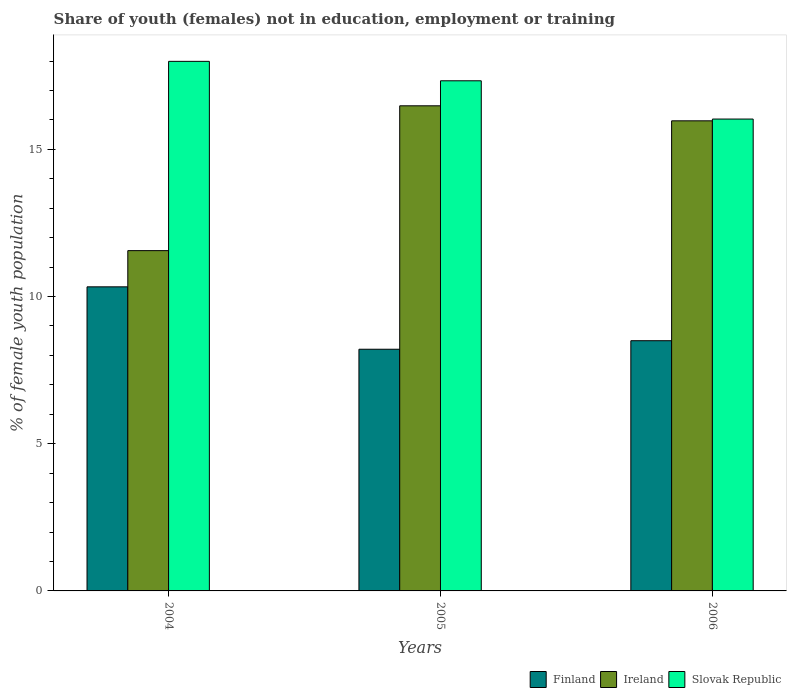How many groups of bars are there?
Give a very brief answer. 3. Are the number of bars on each tick of the X-axis equal?
Make the answer very short. Yes. What is the percentage of unemployed female population in in Slovak Republic in 2004?
Ensure brevity in your answer.  17.99. Across all years, what is the maximum percentage of unemployed female population in in Ireland?
Provide a short and direct response. 16.48. Across all years, what is the minimum percentage of unemployed female population in in Slovak Republic?
Offer a very short reply. 16.03. What is the total percentage of unemployed female population in in Ireland in the graph?
Your response must be concise. 44.01. What is the difference between the percentage of unemployed female population in in Finland in 2004 and that in 2005?
Provide a short and direct response. 2.12. What is the difference between the percentage of unemployed female population in in Ireland in 2005 and the percentage of unemployed female population in in Slovak Republic in 2006?
Make the answer very short. 0.45. What is the average percentage of unemployed female population in in Finland per year?
Keep it short and to the point. 9.01. In the year 2005, what is the difference between the percentage of unemployed female population in in Finland and percentage of unemployed female population in in Slovak Republic?
Keep it short and to the point. -9.12. In how many years, is the percentage of unemployed female population in in Slovak Republic greater than 6 %?
Make the answer very short. 3. What is the ratio of the percentage of unemployed female population in in Slovak Republic in 2005 to that in 2006?
Provide a short and direct response. 1.08. Is the difference between the percentage of unemployed female population in in Finland in 2005 and 2006 greater than the difference between the percentage of unemployed female population in in Slovak Republic in 2005 and 2006?
Your answer should be very brief. No. What is the difference between the highest and the second highest percentage of unemployed female population in in Ireland?
Your response must be concise. 0.51. What is the difference between the highest and the lowest percentage of unemployed female population in in Slovak Republic?
Keep it short and to the point. 1.96. In how many years, is the percentage of unemployed female population in in Slovak Republic greater than the average percentage of unemployed female population in in Slovak Republic taken over all years?
Offer a terse response. 2. What does the 2nd bar from the left in 2005 represents?
Your answer should be very brief. Ireland. What does the 2nd bar from the right in 2004 represents?
Offer a very short reply. Ireland. Are all the bars in the graph horizontal?
Your response must be concise. No. What is the difference between two consecutive major ticks on the Y-axis?
Provide a short and direct response. 5. Does the graph contain any zero values?
Your answer should be very brief. No. How many legend labels are there?
Provide a short and direct response. 3. What is the title of the graph?
Your answer should be compact. Share of youth (females) not in education, employment or training. Does "European Union" appear as one of the legend labels in the graph?
Offer a terse response. No. What is the label or title of the Y-axis?
Offer a very short reply. % of female youth population. What is the % of female youth population of Finland in 2004?
Offer a very short reply. 10.33. What is the % of female youth population of Ireland in 2004?
Your response must be concise. 11.56. What is the % of female youth population of Slovak Republic in 2004?
Make the answer very short. 17.99. What is the % of female youth population in Finland in 2005?
Your response must be concise. 8.21. What is the % of female youth population of Ireland in 2005?
Keep it short and to the point. 16.48. What is the % of female youth population of Slovak Republic in 2005?
Your answer should be compact. 17.33. What is the % of female youth population in Ireland in 2006?
Make the answer very short. 15.97. What is the % of female youth population of Slovak Republic in 2006?
Give a very brief answer. 16.03. Across all years, what is the maximum % of female youth population in Finland?
Make the answer very short. 10.33. Across all years, what is the maximum % of female youth population in Ireland?
Ensure brevity in your answer.  16.48. Across all years, what is the maximum % of female youth population in Slovak Republic?
Provide a succinct answer. 17.99. Across all years, what is the minimum % of female youth population in Finland?
Offer a terse response. 8.21. Across all years, what is the minimum % of female youth population in Ireland?
Make the answer very short. 11.56. Across all years, what is the minimum % of female youth population of Slovak Republic?
Provide a short and direct response. 16.03. What is the total % of female youth population in Finland in the graph?
Offer a terse response. 27.04. What is the total % of female youth population of Ireland in the graph?
Provide a short and direct response. 44.01. What is the total % of female youth population in Slovak Republic in the graph?
Make the answer very short. 51.35. What is the difference between the % of female youth population of Finland in 2004 and that in 2005?
Give a very brief answer. 2.12. What is the difference between the % of female youth population of Ireland in 2004 and that in 2005?
Ensure brevity in your answer.  -4.92. What is the difference between the % of female youth population of Slovak Republic in 2004 and that in 2005?
Your answer should be compact. 0.66. What is the difference between the % of female youth population in Finland in 2004 and that in 2006?
Ensure brevity in your answer.  1.83. What is the difference between the % of female youth population in Ireland in 2004 and that in 2006?
Give a very brief answer. -4.41. What is the difference between the % of female youth population in Slovak Republic in 2004 and that in 2006?
Ensure brevity in your answer.  1.96. What is the difference between the % of female youth population in Finland in 2005 and that in 2006?
Keep it short and to the point. -0.29. What is the difference between the % of female youth population in Ireland in 2005 and that in 2006?
Give a very brief answer. 0.51. What is the difference between the % of female youth population in Slovak Republic in 2005 and that in 2006?
Provide a succinct answer. 1.3. What is the difference between the % of female youth population of Finland in 2004 and the % of female youth population of Ireland in 2005?
Offer a terse response. -6.15. What is the difference between the % of female youth population of Finland in 2004 and the % of female youth population of Slovak Republic in 2005?
Ensure brevity in your answer.  -7. What is the difference between the % of female youth population of Ireland in 2004 and the % of female youth population of Slovak Republic in 2005?
Provide a short and direct response. -5.77. What is the difference between the % of female youth population in Finland in 2004 and the % of female youth population in Ireland in 2006?
Make the answer very short. -5.64. What is the difference between the % of female youth population of Finland in 2004 and the % of female youth population of Slovak Republic in 2006?
Provide a succinct answer. -5.7. What is the difference between the % of female youth population of Ireland in 2004 and the % of female youth population of Slovak Republic in 2006?
Give a very brief answer. -4.47. What is the difference between the % of female youth population in Finland in 2005 and the % of female youth population in Ireland in 2006?
Your answer should be very brief. -7.76. What is the difference between the % of female youth population of Finland in 2005 and the % of female youth population of Slovak Republic in 2006?
Offer a very short reply. -7.82. What is the difference between the % of female youth population in Ireland in 2005 and the % of female youth population in Slovak Republic in 2006?
Provide a succinct answer. 0.45. What is the average % of female youth population in Finland per year?
Provide a succinct answer. 9.01. What is the average % of female youth population of Ireland per year?
Provide a short and direct response. 14.67. What is the average % of female youth population of Slovak Republic per year?
Ensure brevity in your answer.  17.12. In the year 2004, what is the difference between the % of female youth population of Finland and % of female youth population of Ireland?
Keep it short and to the point. -1.23. In the year 2004, what is the difference between the % of female youth population of Finland and % of female youth population of Slovak Republic?
Offer a very short reply. -7.66. In the year 2004, what is the difference between the % of female youth population of Ireland and % of female youth population of Slovak Republic?
Your answer should be compact. -6.43. In the year 2005, what is the difference between the % of female youth population of Finland and % of female youth population of Ireland?
Ensure brevity in your answer.  -8.27. In the year 2005, what is the difference between the % of female youth population of Finland and % of female youth population of Slovak Republic?
Offer a very short reply. -9.12. In the year 2005, what is the difference between the % of female youth population of Ireland and % of female youth population of Slovak Republic?
Your response must be concise. -0.85. In the year 2006, what is the difference between the % of female youth population in Finland and % of female youth population in Ireland?
Your answer should be compact. -7.47. In the year 2006, what is the difference between the % of female youth population of Finland and % of female youth population of Slovak Republic?
Make the answer very short. -7.53. In the year 2006, what is the difference between the % of female youth population of Ireland and % of female youth population of Slovak Republic?
Ensure brevity in your answer.  -0.06. What is the ratio of the % of female youth population in Finland in 2004 to that in 2005?
Your answer should be compact. 1.26. What is the ratio of the % of female youth population of Ireland in 2004 to that in 2005?
Offer a terse response. 0.7. What is the ratio of the % of female youth population of Slovak Republic in 2004 to that in 2005?
Make the answer very short. 1.04. What is the ratio of the % of female youth population in Finland in 2004 to that in 2006?
Provide a short and direct response. 1.22. What is the ratio of the % of female youth population in Ireland in 2004 to that in 2006?
Provide a short and direct response. 0.72. What is the ratio of the % of female youth population in Slovak Republic in 2004 to that in 2006?
Offer a terse response. 1.12. What is the ratio of the % of female youth population in Finland in 2005 to that in 2006?
Provide a short and direct response. 0.97. What is the ratio of the % of female youth population of Ireland in 2005 to that in 2006?
Your response must be concise. 1.03. What is the ratio of the % of female youth population of Slovak Republic in 2005 to that in 2006?
Make the answer very short. 1.08. What is the difference between the highest and the second highest % of female youth population in Finland?
Provide a succinct answer. 1.83. What is the difference between the highest and the second highest % of female youth population in Ireland?
Your answer should be very brief. 0.51. What is the difference between the highest and the second highest % of female youth population in Slovak Republic?
Make the answer very short. 0.66. What is the difference between the highest and the lowest % of female youth population in Finland?
Give a very brief answer. 2.12. What is the difference between the highest and the lowest % of female youth population of Ireland?
Offer a very short reply. 4.92. What is the difference between the highest and the lowest % of female youth population of Slovak Republic?
Make the answer very short. 1.96. 